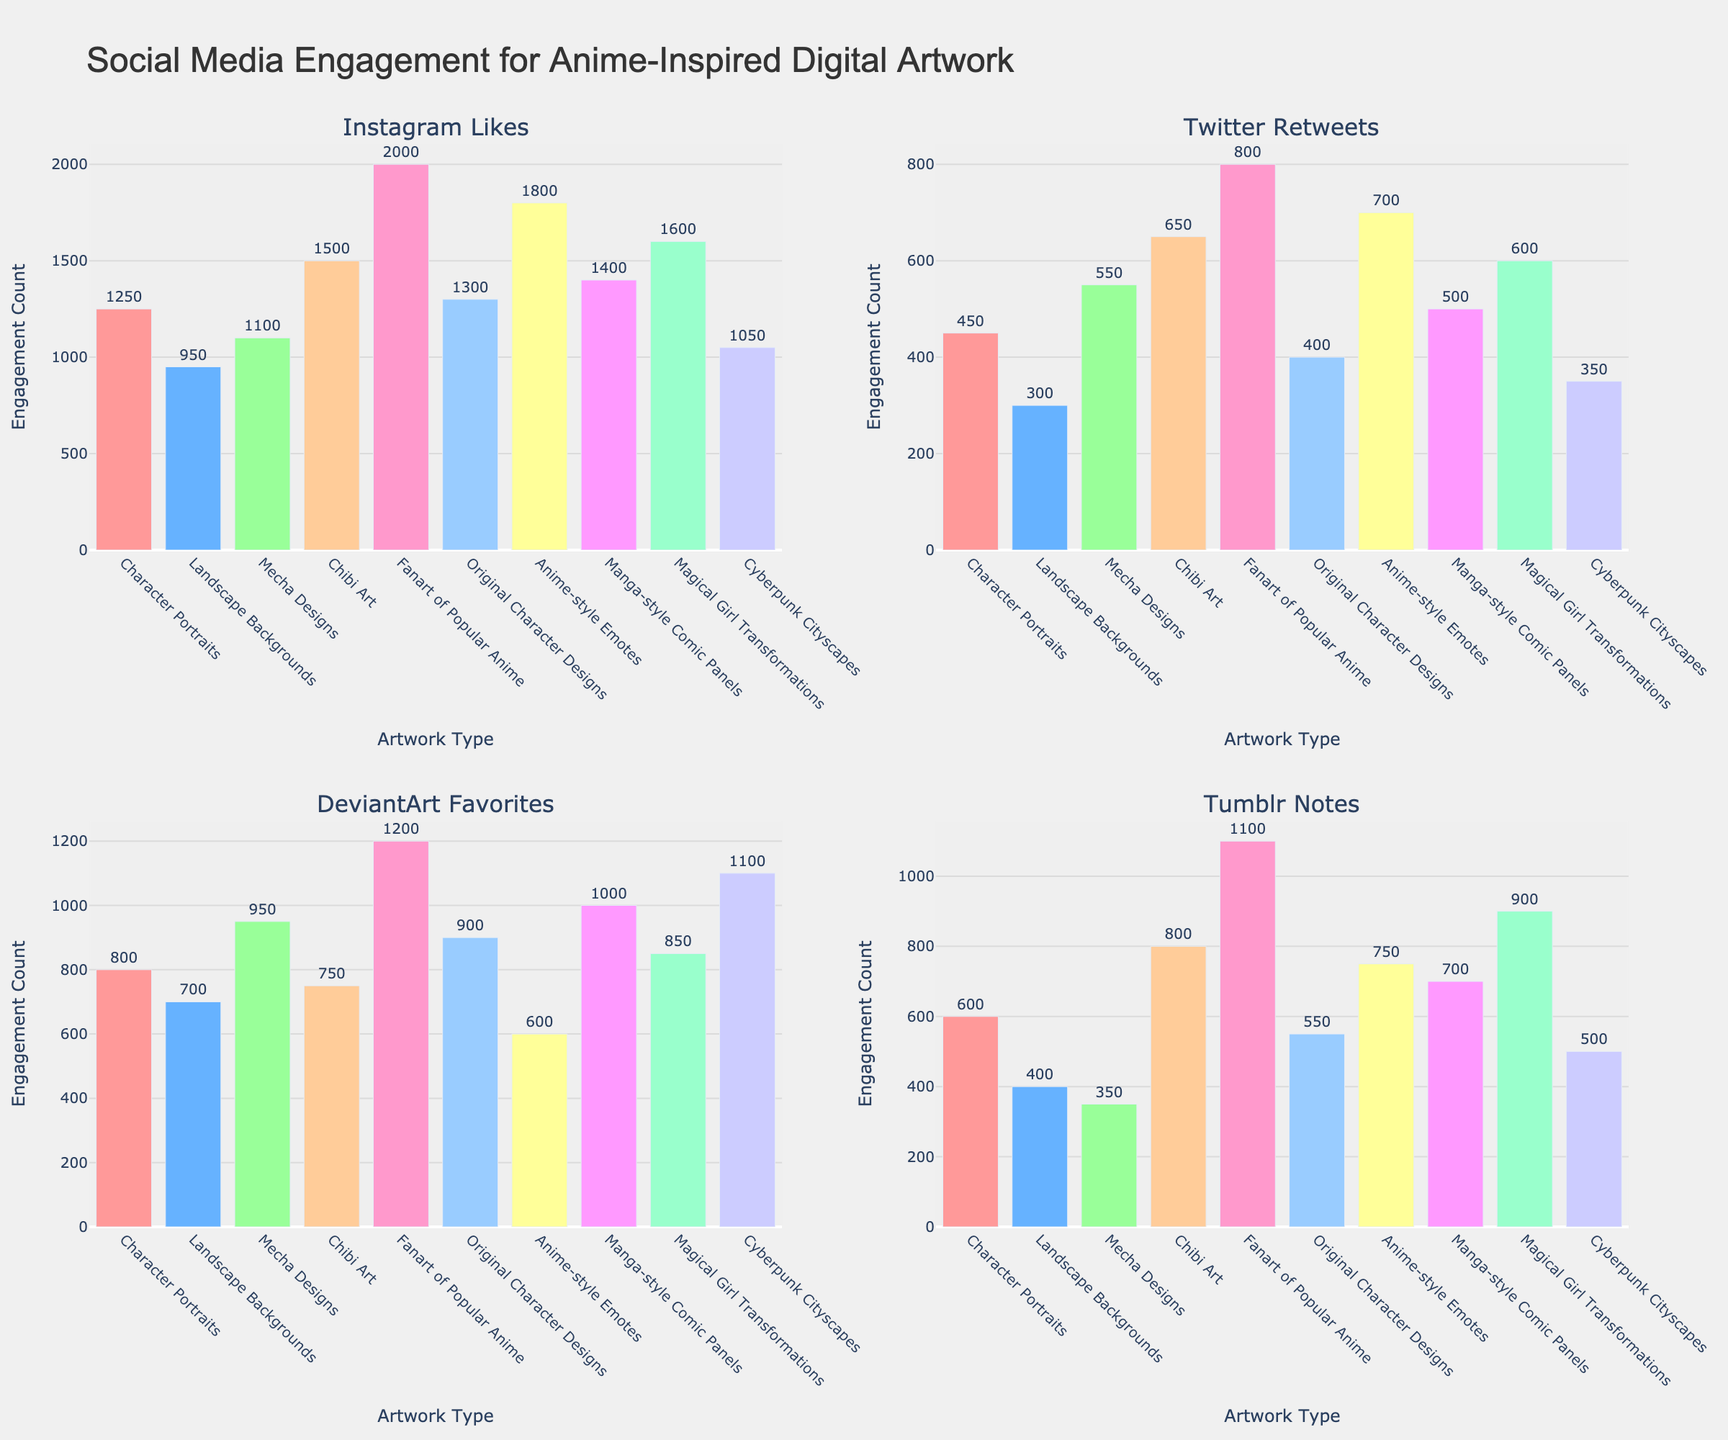What is the most expensive monthly premium for a Small Business? The figure shows bars representing monthly premiums for different types of insurance policies across various business sizes. By examining the bars labeled for "Small Business", the highest value is under "Property Insurance" at $100.
Answer: $100 Which insurance type has the lowest monthly premium for Medium Business? Looking at the bars for "Medium Business" across all subplots, the shortest bar (indicating the lowest value) is under "Business Interruption" at $90.
Answer: $90 How much more is the monthly premium for Workers' Compensation for a Large Business compared to a Small Business? Observe the bars for "Workers' Compensation" for both "Large Business" and "Small Business". The values are $600 and $75 respectively. Calculate the difference as $600 - $75 = $525.
Answer: $525 What is the average monthly premium for a Medium Business across all insurance types? Sum the premiums for "Medium Business" across all subplots: $150 (General), $300 (Property), $225 (Workers), $180 (Professional), $240 (Commercial Auto), $120 (Cyber), $90 (Business Interruption), and $135 (Product) and divide by the number of types (8). The sum is $1440. Thus, the average is $1440 / 8 = $180.
Answer: $180 Which business size has the lowest average monthly premium across all insurance types? Average the premiums for Small Business, Medium Business, and Large Business. For Small Business: (50 + 100 + 75 + 60 + 80 + 40 + 30 + 45) / 8 = 60. For Medium Business: (150 + 300 + 225 + 180 + 240 + 120 + 90 + 135) / 8 = 180. For Large Business: (400 + 800 + 600 + 450 + 650 + 350 + 250 + 375) / 8 = 487.5. Small Business has the lowest average of $60.
Answer: Small Business What is the title of the figure? The title is located at the top of the plot and reads, "Monthly Premium Costs for Various Business Insurance Policies".
Answer: Monthly Premium Costs for Various Business Insurance Policies Which insurance type shows the highest variability in premiums across different business sizes? Observing the differences between the highest and lowest premiums for each insurance type, "Property Insurance" has the widest range from $100 (Small) to $800 (Large). The variability is $800 - $100 = $700.
Answer: Property Insurance What is the combined monthly premium for General Liability and Professional Liability insurance for a Medium Business? Sum the bars for "General Liability" ($150) and "Professional Liability" ($180) under "Medium Business". $150 + $180 = $330.
Answer: $330 